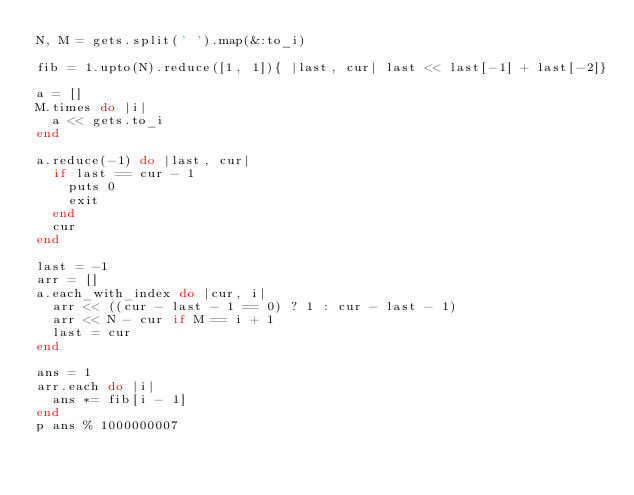Convert code to text. <code><loc_0><loc_0><loc_500><loc_500><_Ruby_>N, M = gets.split(' ').map(&:to_i)

fib = 1.upto(N).reduce([1, 1]){ |last, cur| last << last[-1] + last[-2]}

a = []
M.times do |i|
  a << gets.to_i
end

a.reduce(-1) do |last, cur|
  if last == cur - 1
    puts 0
    exit
  end
  cur
end

last = -1
arr = []
a.each_with_index do |cur, i|
  arr << ((cur - last - 1 == 0) ? 1 : cur - last - 1)
  arr << N - cur if M == i + 1 
  last = cur
end

ans = 1
arr.each do |i|
  ans *= fib[i - 1]
end
p ans % 1000000007</code> 